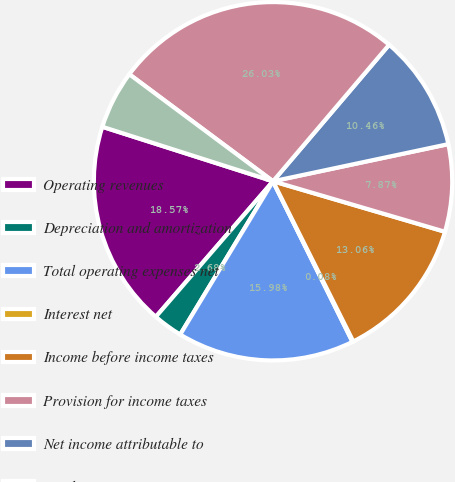Convert chart to OTSL. <chart><loc_0><loc_0><loc_500><loc_500><pie_chart><fcel>Operating revenues<fcel>Depreciation and amortization<fcel>Total operating expenses net<fcel>Interest net<fcel>Income before income taxes<fcel>Provision for income taxes<fcel>Net income attributable to<fcel>Total assets<fcel>Capital expenditures<nl><fcel>18.57%<fcel>2.68%<fcel>15.98%<fcel>0.08%<fcel>13.06%<fcel>7.87%<fcel>10.46%<fcel>26.03%<fcel>5.27%<nl></chart> 